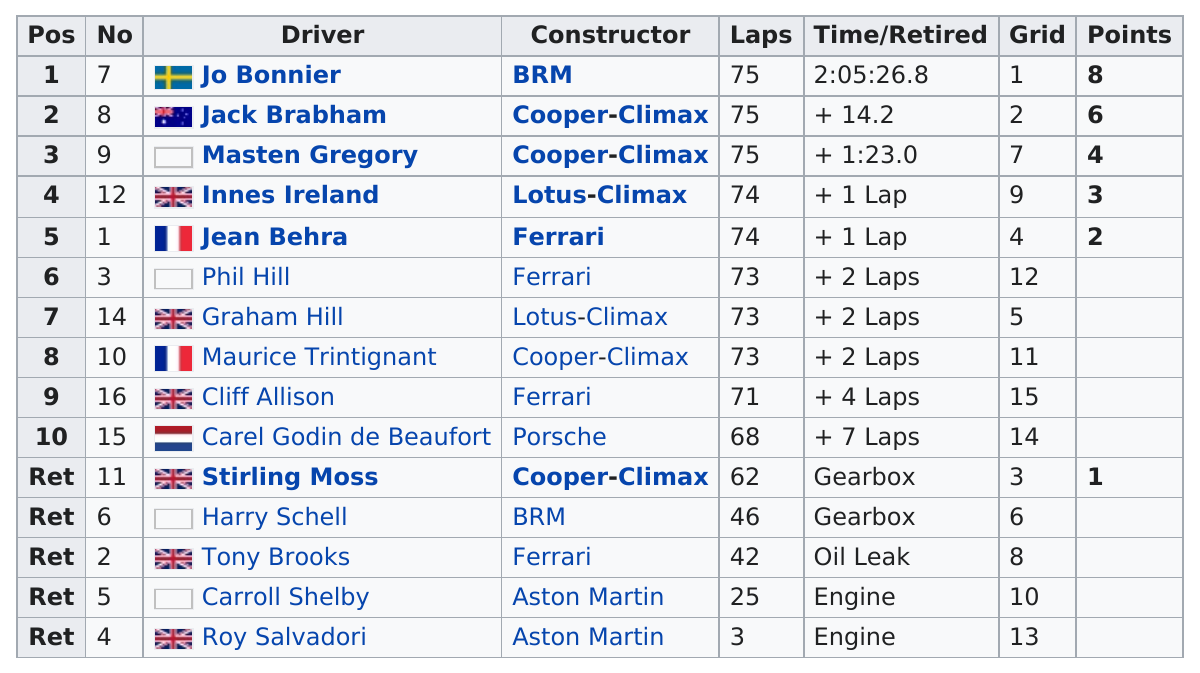Point out several critical features in this image. Four drivers drove a Ferrari in the race. Jo Bonnier finished all 75 laps in a total time of 2 hours and 5 minutes and 26.8 seconds. Jo Bonnier is a driver who has scored at least 5 points. Jo Bonnier scored the most points. Phil Hill drove a total of 73 laps. 